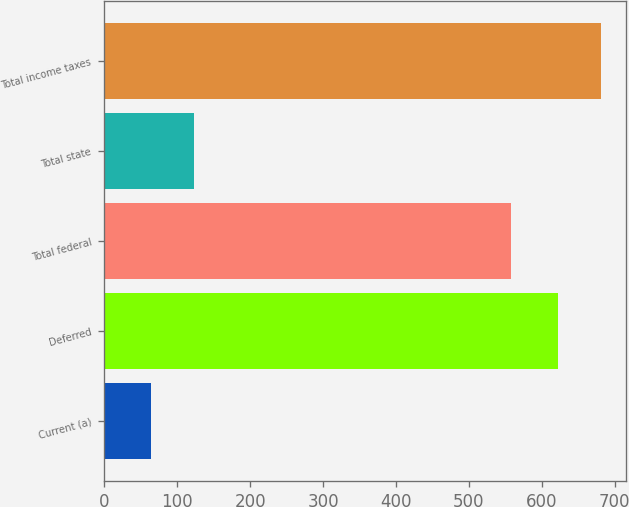Convert chart to OTSL. <chart><loc_0><loc_0><loc_500><loc_500><bar_chart><fcel>Current (a)<fcel>Deferred<fcel>Total federal<fcel>Total state<fcel>Total income taxes<nl><fcel>64<fcel>622<fcel>558<fcel>123<fcel>681<nl></chart> 